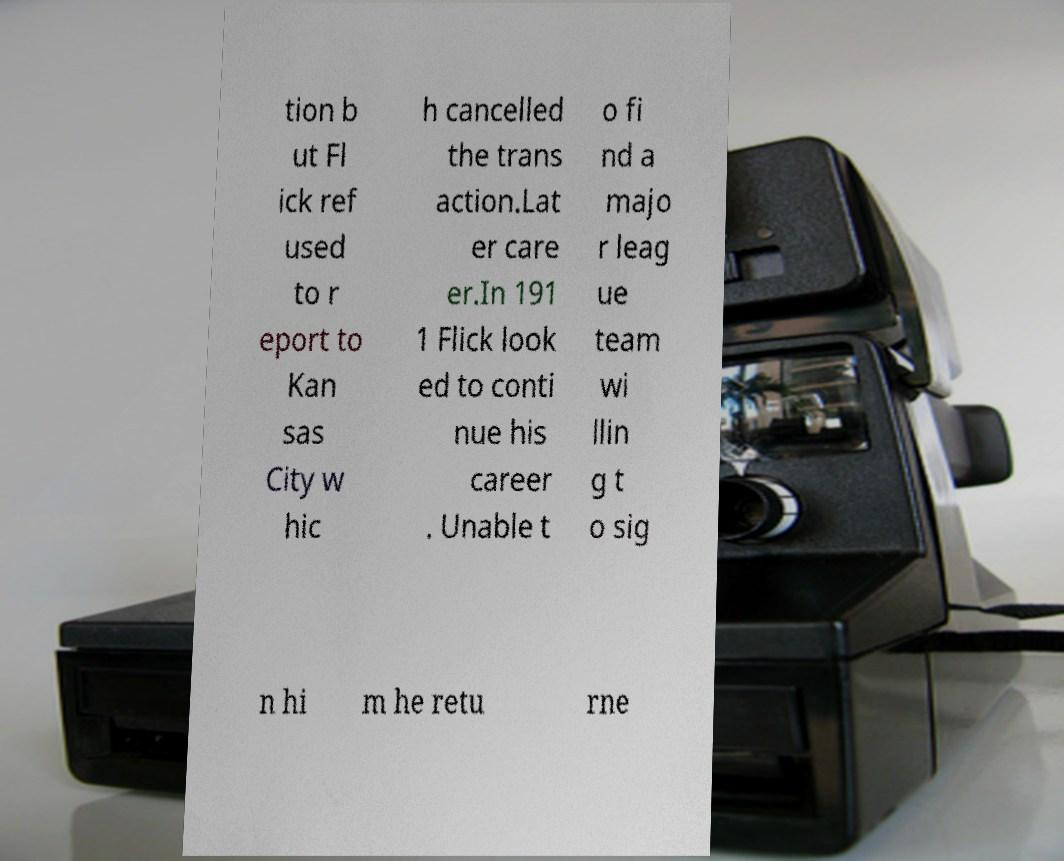For documentation purposes, I need the text within this image transcribed. Could you provide that? tion b ut Fl ick ref used to r eport to Kan sas City w hic h cancelled the trans action.Lat er care er.In 191 1 Flick look ed to conti nue his career . Unable t o fi nd a majo r leag ue team wi llin g t o sig n hi m he retu rne 